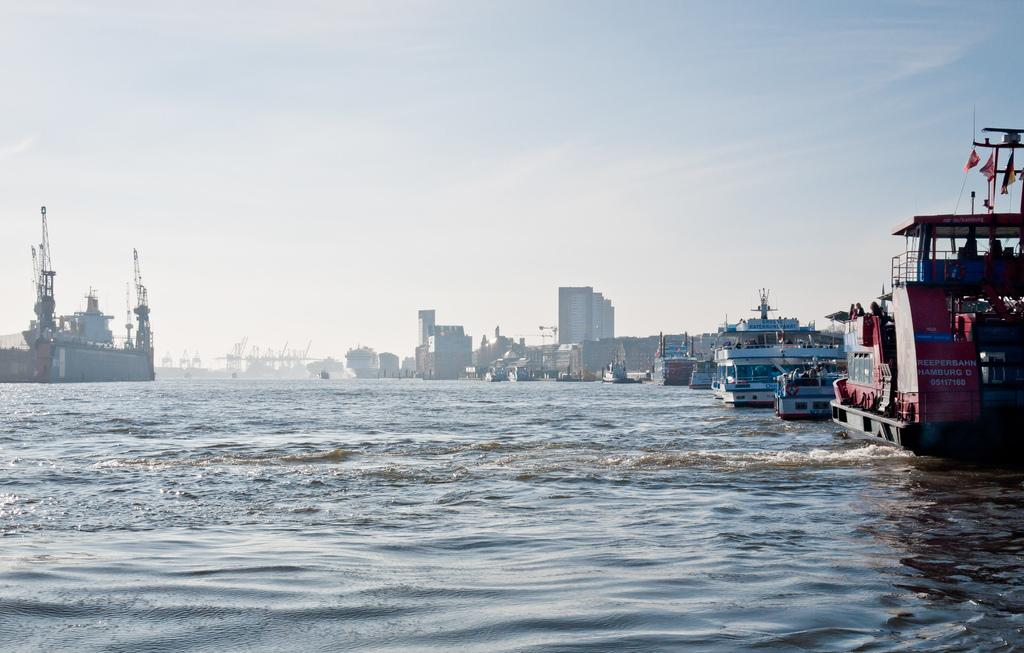What is the primary element visible in the image? There is water in the image. What types of watercraft can be seen in the image? There are many boats and ships in the image. What can be seen in the background of the image? There are buildings and the sky visible in the background of the image. Can you hear the grandfather playing the drum in the image? There is no grandfather or drum present in the image. 